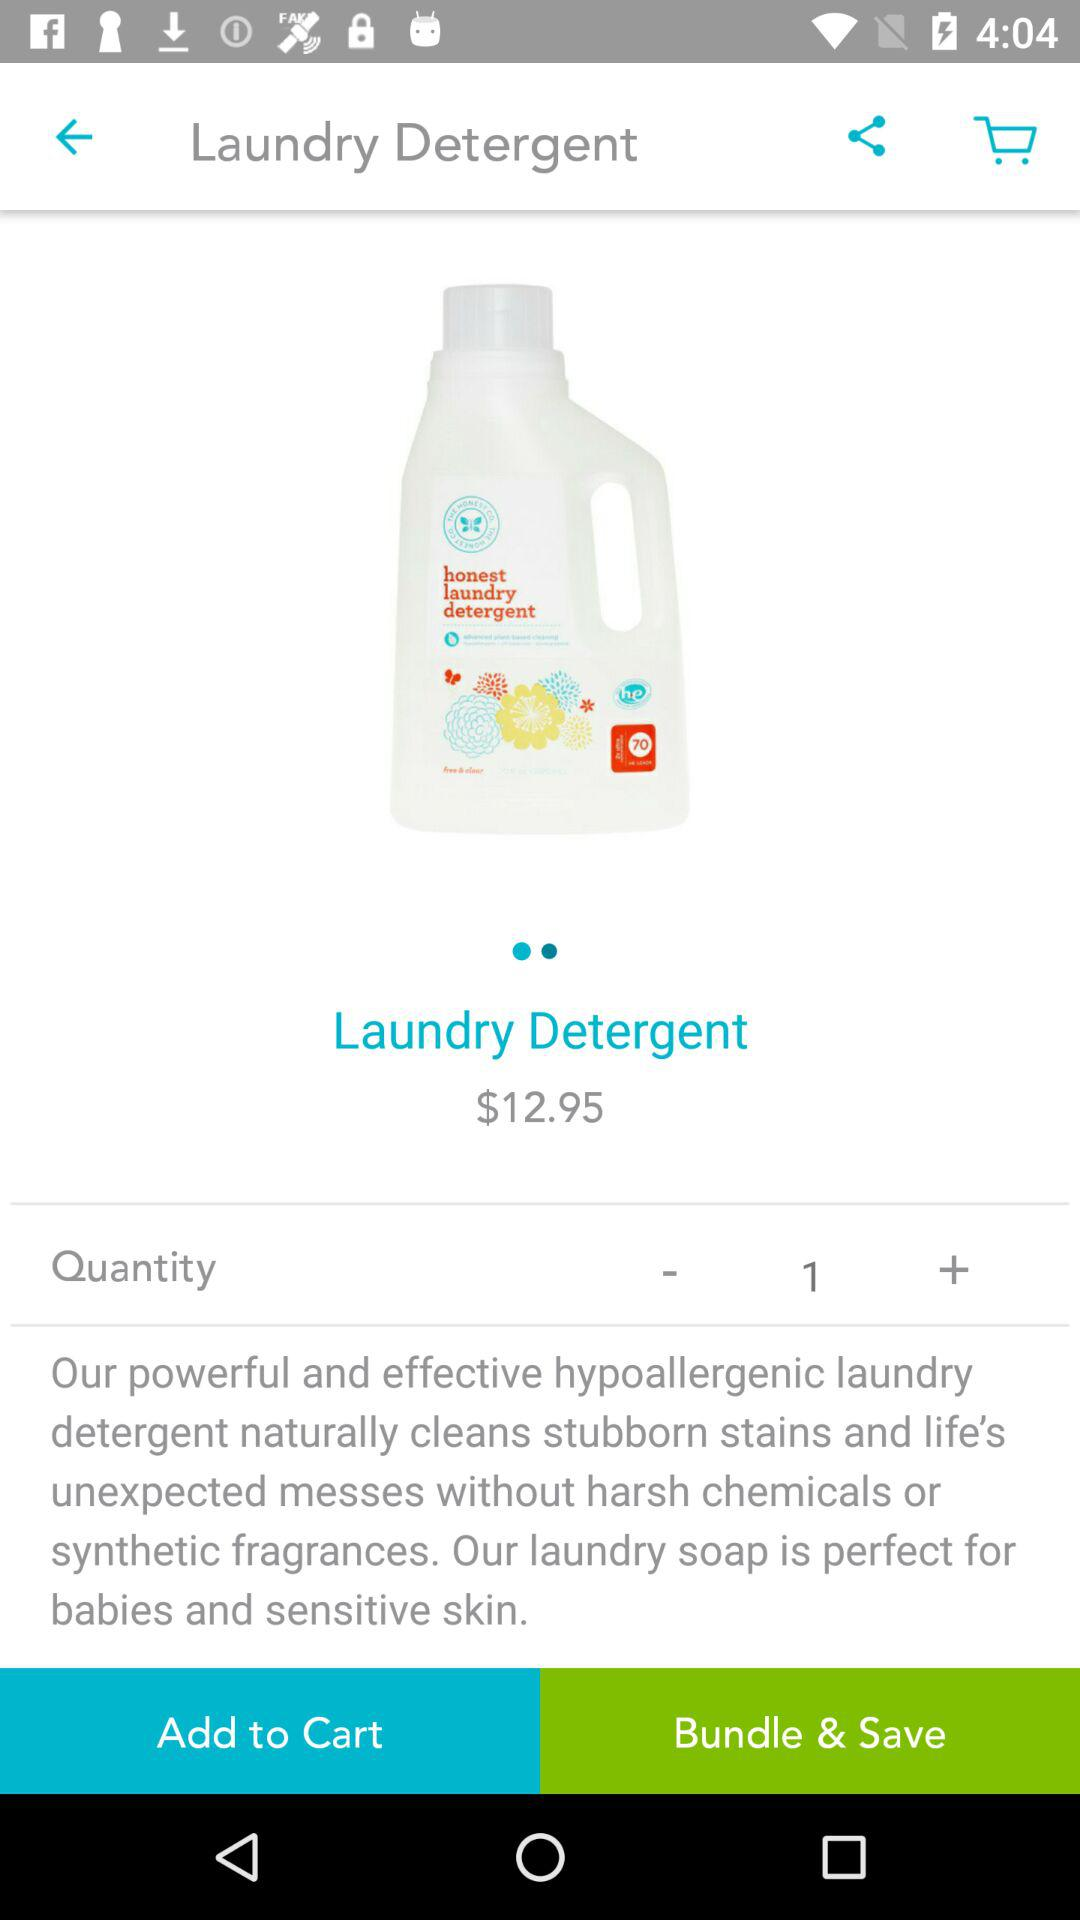What is the price of "Laundry Detergent"? The price of "Laundry Detergent" is $12.95. 